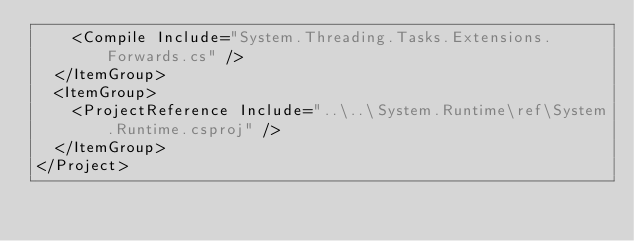<code> <loc_0><loc_0><loc_500><loc_500><_XML_>    <Compile Include="System.Threading.Tasks.Extensions.Forwards.cs" />
  </ItemGroup>
  <ItemGroup>
    <ProjectReference Include="..\..\System.Runtime\ref\System.Runtime.csproj" />
  </ItemGroup>
</Project>
</code> 